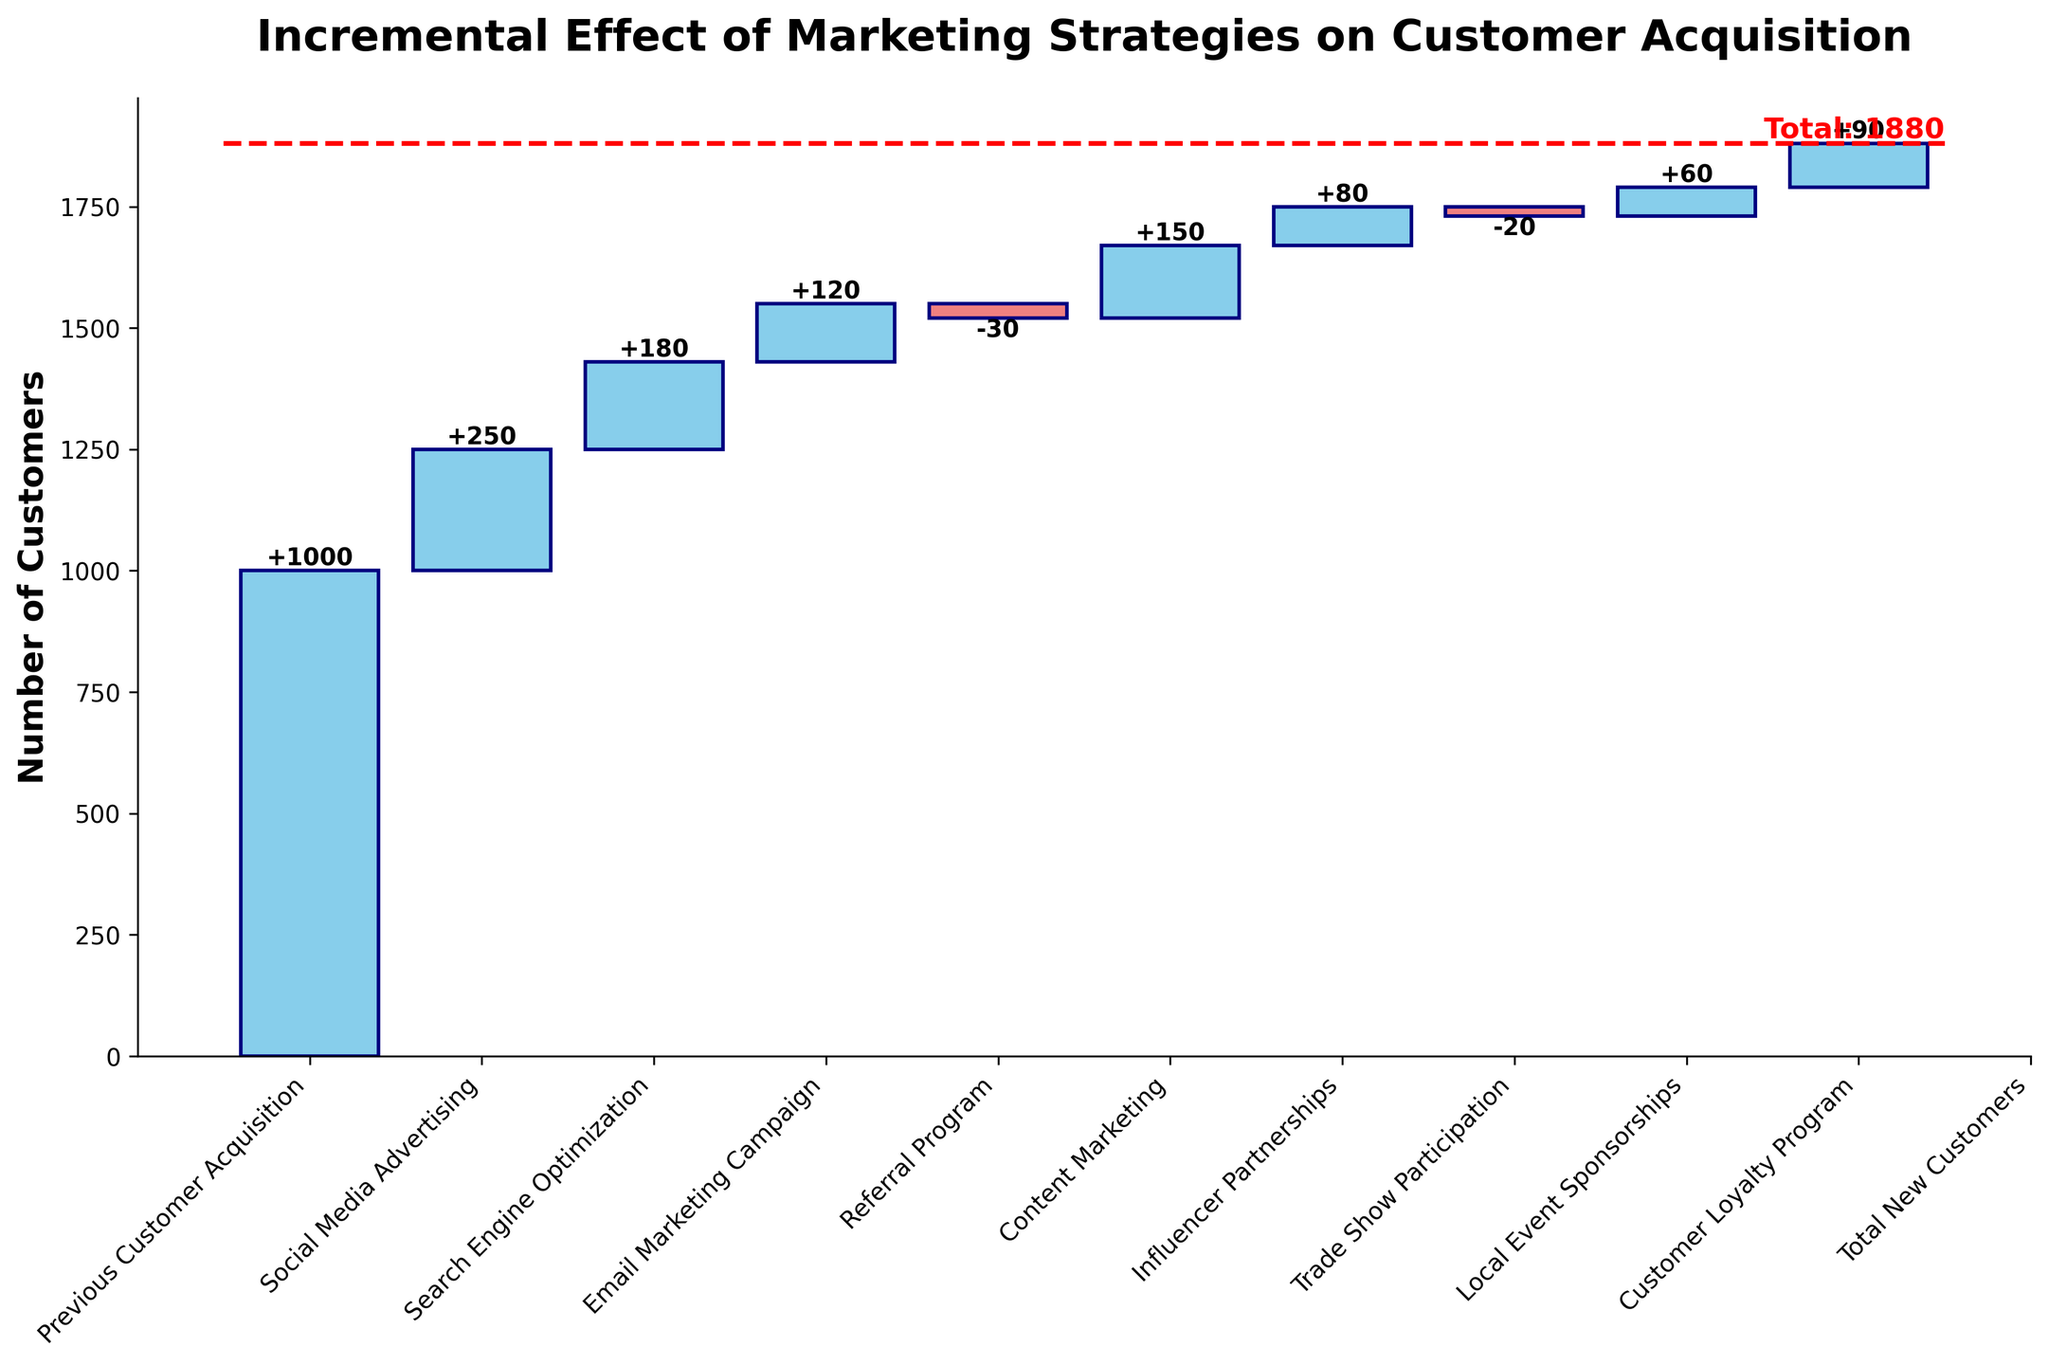What's the title of the chart? The title of the chart is written at the top, usually in larger and bold fonts compared to other text. Here, it reads "Incremental Effect of Marketing Strategies on Customer Acquisition".
Answer: Incremental Effect of Marketing Strategies on Customer Acquisition How many marketing strategies are shown in the chart? Each bar in the waterfall chart represents one marketing strategy, so you count the number of bars. There are 9 bars representing different strategies.
Answer: 9 Which strategy had the most positive impact on customer acquisition? To answer this, compare the heights of the blue bars. The tallest blue bar corresponds to Social Media Advertising, with an impact of +250.
Answer: Social Media Advertising What is the total number of new customers acquired? The total line is shown in red dashed lines, and the text next to it states "Total: 1880".
Answer: 1880 What is the cumulative impact of Social Media Advertising and Search Engine Optimization? Add the impact values of Social Media Advertising (+250) and Search Engine Optimization (+180). The sum is 430.
Answer: 430 Which strategy had the smallest positive impact? The smallest blue bar indicating a positive impact is associated with Influencer Partnerships, with an impact of +80.
Answer: Influencer Partnerships How did the Referral Program impact customer acquisition? The bar color changes to light coral for negative impacts. The impact of the Referral Program is shown as -30.
Answer: -30 What is the net impact of Email Marketing Campaign and Trade Show Participation? Sum the impact values of Email Marketing Campaign (+120) and Trade Show Participation (-20). The net impact is 100.
Answer: 100 Which marketing strategy has had a negative effect on customer acquisition, and what was the effect? Identify the bars in light coral color and check the label. The Trade Show Participation had a negative impact of -20, and the Referral Program had a negative impact of -30.
Answer: Trade Show Participation: -20, Referral Program: -30 Which three strategies had impacts between +50 and +100? Look for blue bars labeled between +50 and +100. The strategies are Local Event Sponsorships (+60), Influencer Partnerships (+80), and Customer Loyalty Program (+90).
Answer: Local Event Sponsorships, Influencer Partnerships, Customer Loyalty Program 